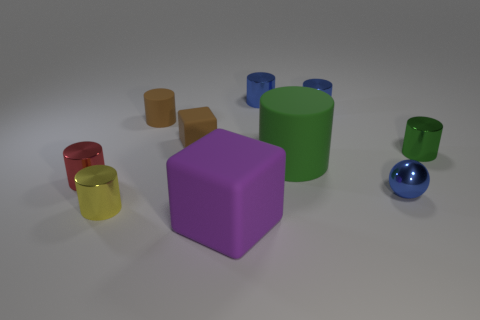Is the shape of the tiny red object the same as the matte object behind the brown matte block? While both the tiny red object and the matte object behind the brown matte block are cylindrical, they differ in size and finish; the red object is smaller and has a reflective surface, while the larger object has a matte finish. 